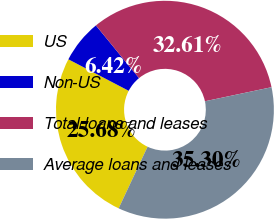Convert chart to OTSL. <chart><loc_0><loc_0><loc_500><loc_500><pie_chart><fcel>US<fcel>Non-US<fcel>Total loans and leases<fcel>Average loans and leases<nl><fcel>25.68%<fcel>6.42%<fcel>32.61%<fcel>35.3%<nl></chart> 